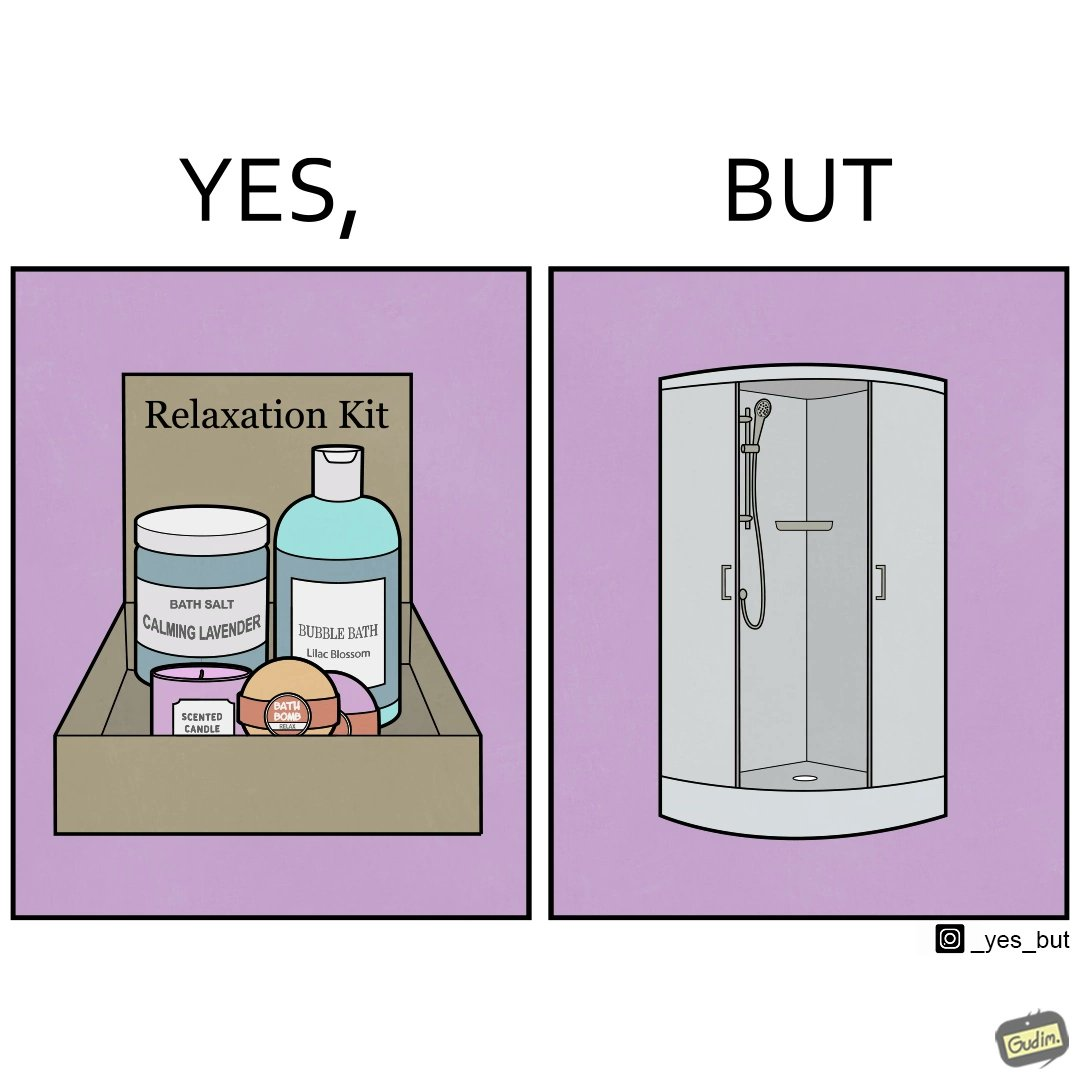Is there satirical content in this image? Yes, this image is satirical. 